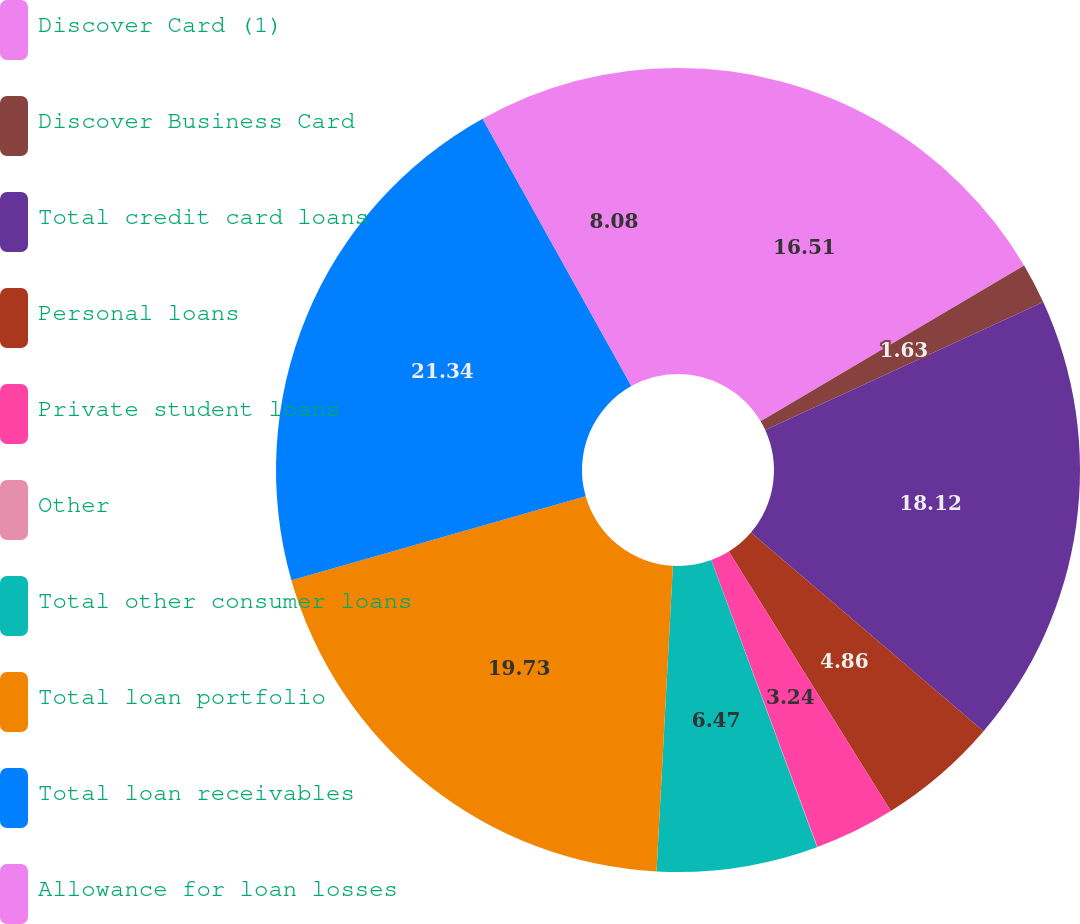<chart> <loc_0><loc_0><loc_500><loc_500><pie_chart><fcel>Discover Card (1)<fcel>Discover Business Card<fcel>Total credit card loans<fcel>Personal loans<fcel>Private student loans<fcel>Other<fcel>Total other consumer loans<fcel>Total loan portfolio<fcel>Total loan receivables<fcel>Allowance for loan losses<nl><fcel>16.51%<fcel>1.63%<fcel>18.12%<fcel>4.86%<fcel>3.24%<fcel>0.02%<fcel>6.47%<fcel>19.73%<fcel>21.34%<fcel>8.08%<nl></chart> 